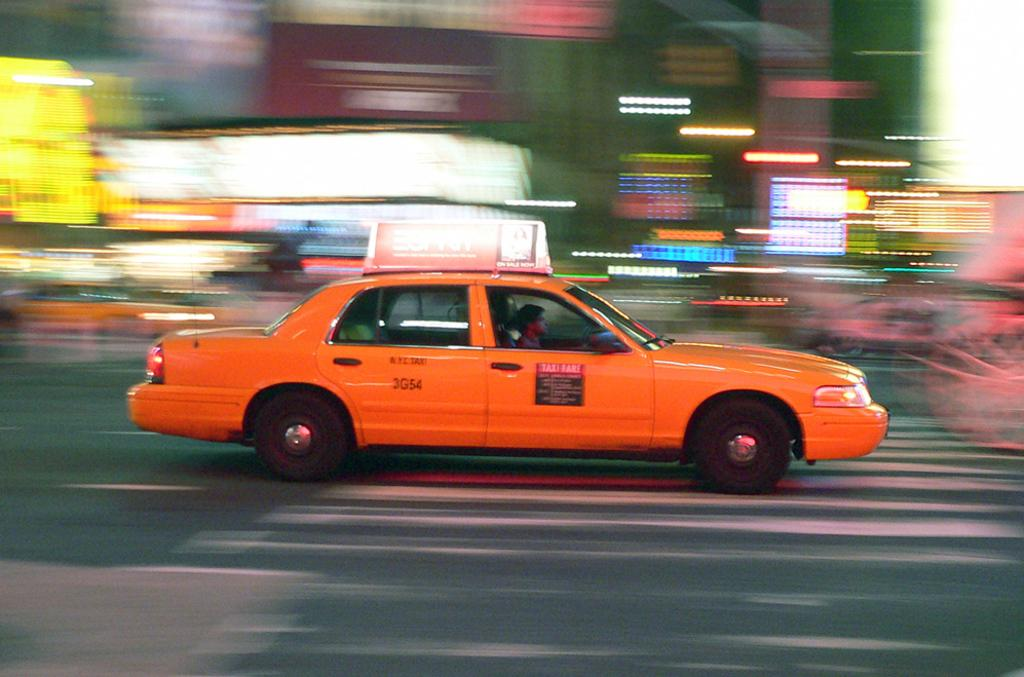Provide a one-sentence caption for the provided image. Taxi 3G54 drives as the passing lights streak across the image. 